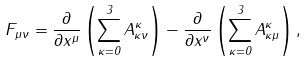Convert formula to latex. <formula><loc_0><loc_0><loc_500><loc_500>F _ { \mu \nu } = \frac { \partial } { \partial x ^ { \mu } } \left ( \sum _ { \kappa = 0 } ^ { 3 } A _ { \kappa \nu } ^ { \kappa } \right ) - \frac { \partial } { \partial x ^ { \nu } } \left ( \sum _ { \kappa = 0 } ^ { 3 } A _ { \kappa \mu } ^ { \kappa } \right ) ,</formula> 